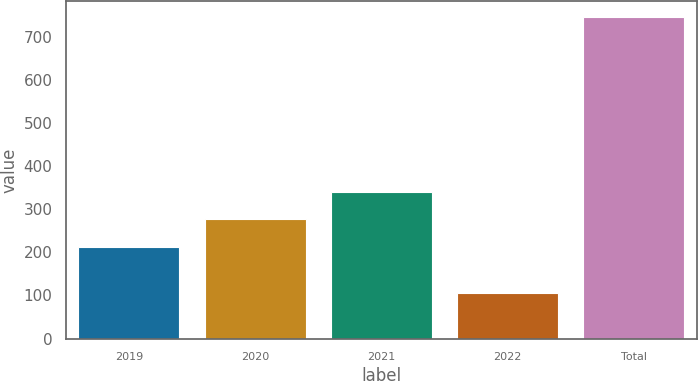Convert chart. <chart><loc_0><loc_0><loc_500><loc_500><bar_chart><fcel>2019<fcel>2020<fcel>2021<fcel>2022<fcel>Total<nl><fcel>213<fcel>276.9<fcel>340.8<fcel>106<fcel>745<nl></chart> 